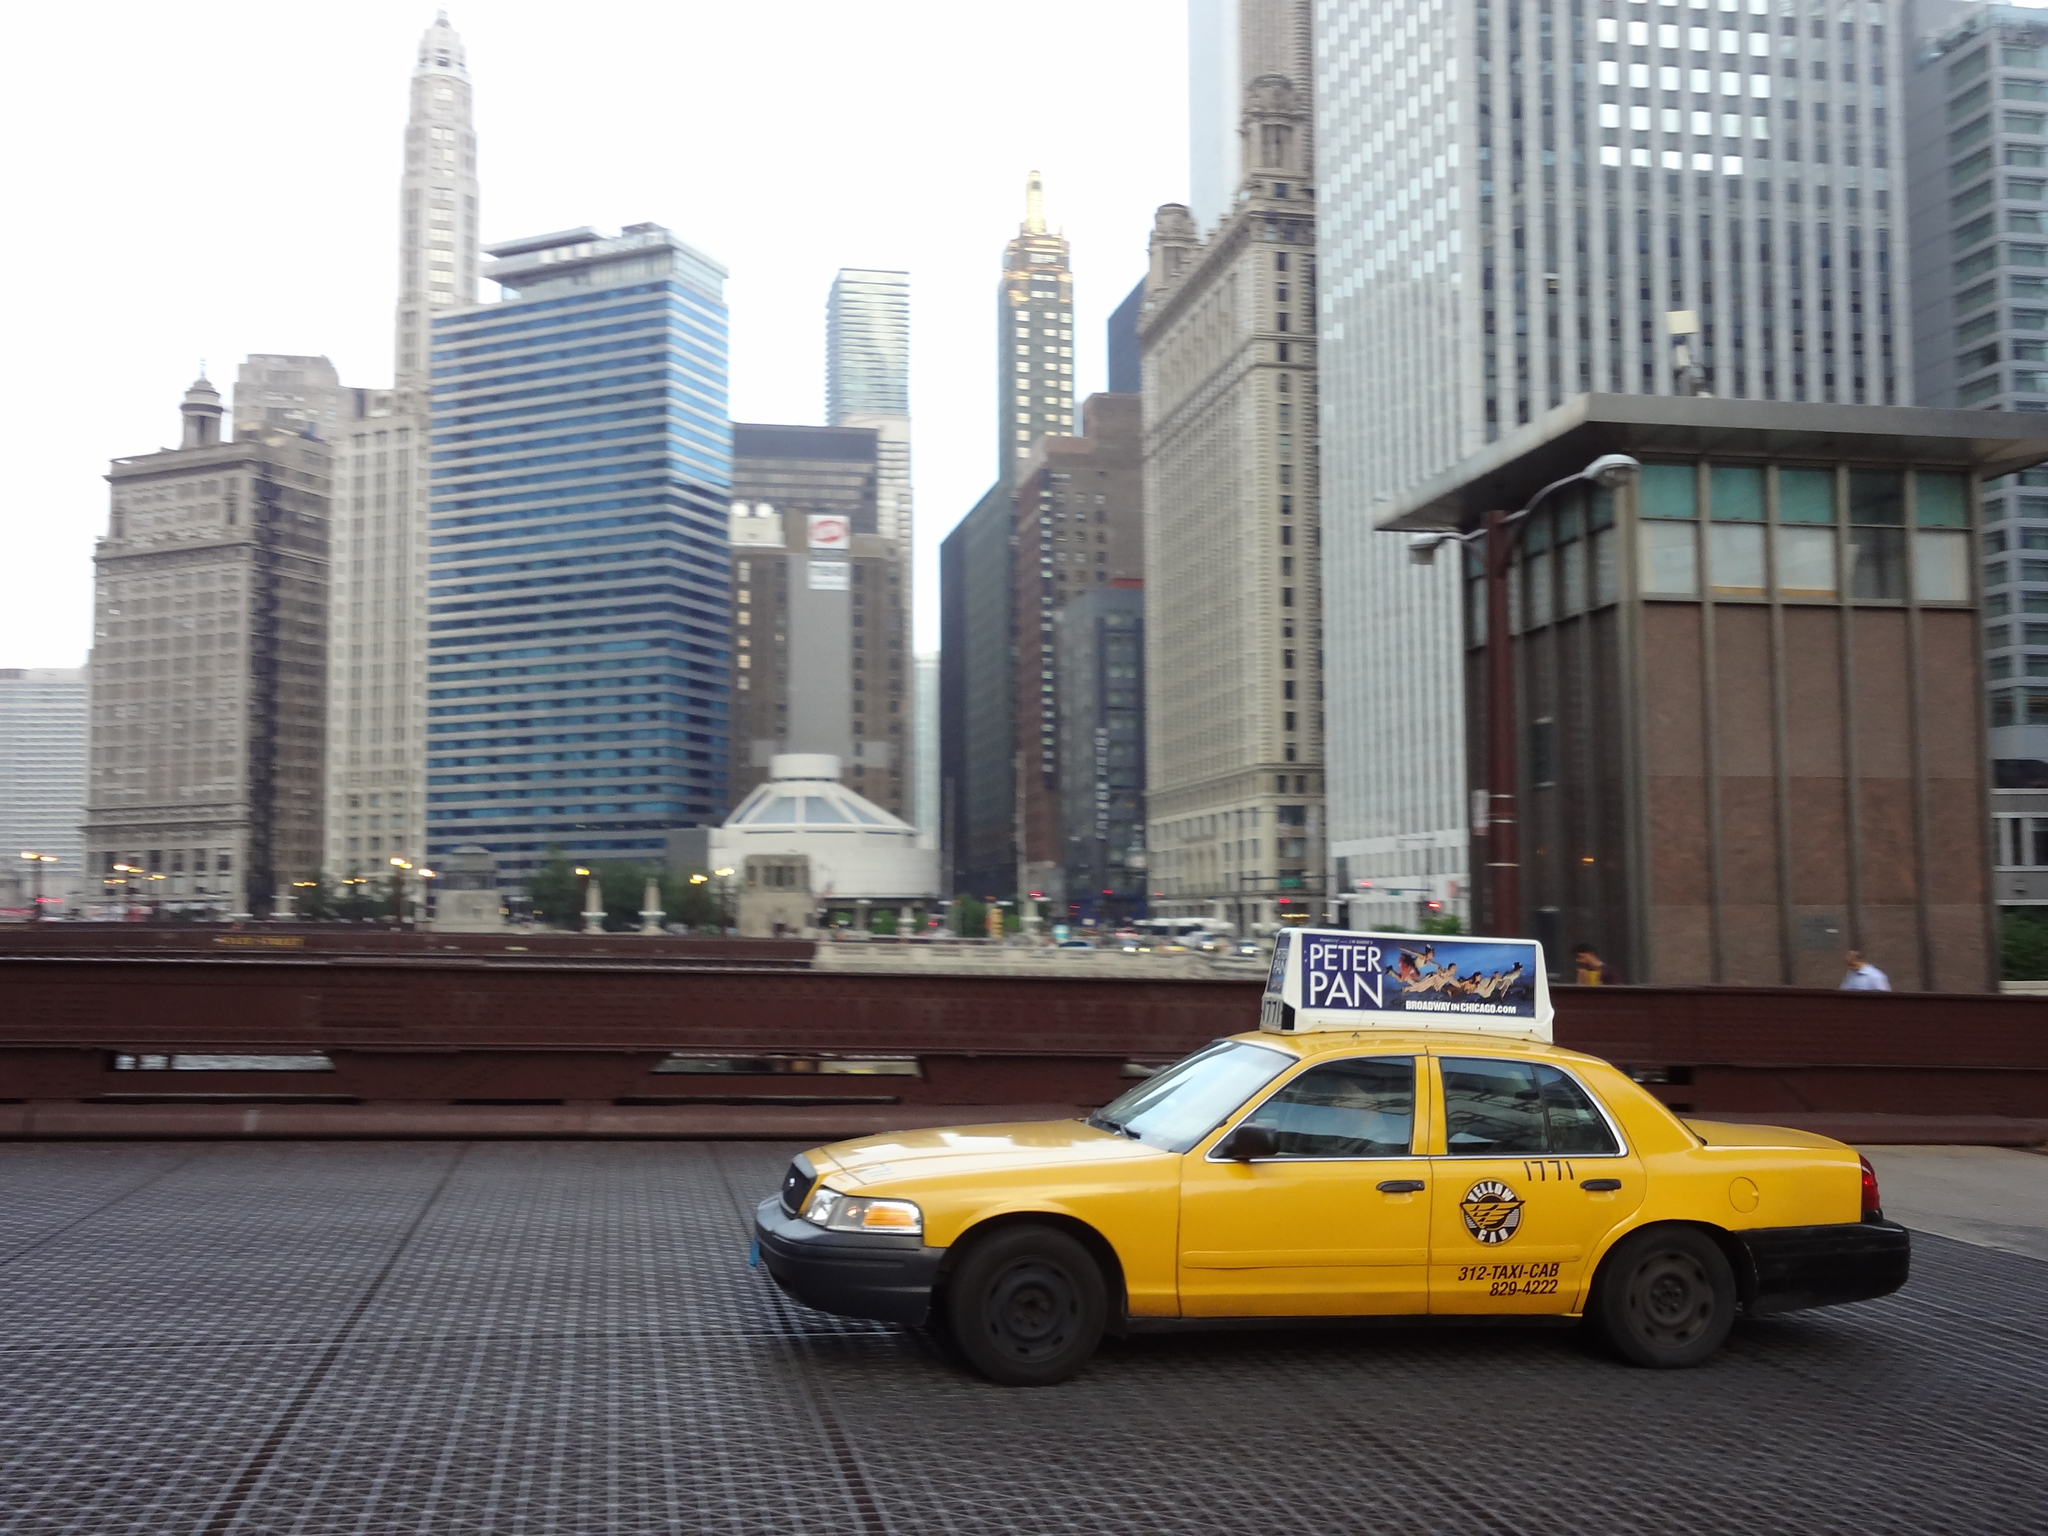What play is advertised on this cab?
Offer a very short reply. Peter pan. What's the name of the taxi company?
Make the answer very short. Unanswerable. 